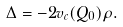Convert formula to latex. <formula><loc_0><loc_0><loc_500><loc_500>\Delta = - 2 v _ { c } ( Q _ { 0 } ) \rho .</formula> 